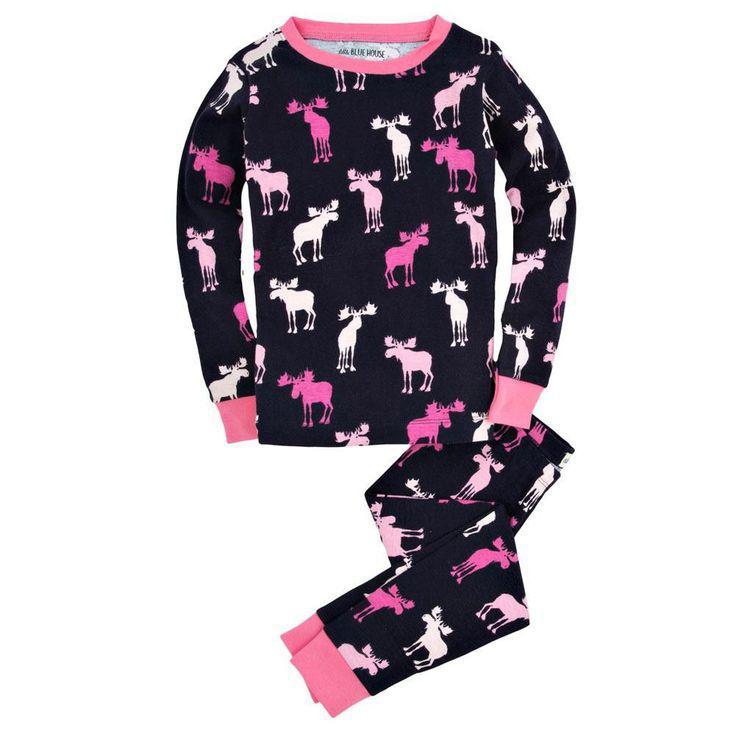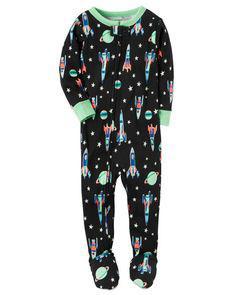The first image is the image on the left, the second image is the image on the right. Evaluate the accuracy of this statement regarding the images: "All the pajamas have long sleeves with small cuffs.". Is it true? Answer yes or no. Yes. The first image is the image on the left, the second image is the image on the right. For the images displayed, is the sentence "At least one of the outfits has a brightly colored collar and brightly colored cuffs around the sleeves or ankles." factually correct? Answer yes or no. Yes. 